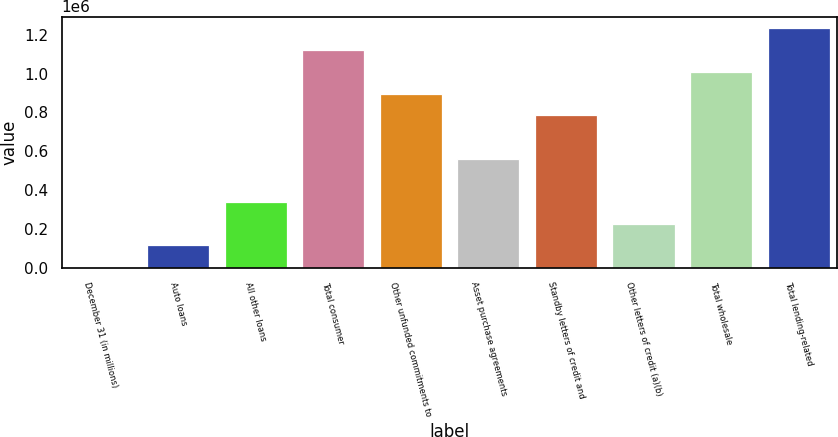Convert chart. <chart><loc_0><loc_0><loc_500><loc_500><bar_chart><fcel>December 31 (in millions)<fcel>Auto loans<fcel>All other loans<fcel>Total consumer<fcel>Other unfunded commitments to<fcel>Asset purchase agreements<fcel>Standby letters of credit and<fcel>Other letters of credit (a)(b)<fcel>Total wholesale<fcel>Total lending-related<nl><fcel>2008<fcel>113945<fcel>337819<fcel>1.12138e+06<fcel>897504<fcel>561693<fcel>785567<fcel>225882<fcel>1.00944e+06<fcel>1.23332e+06<nl></chart> 